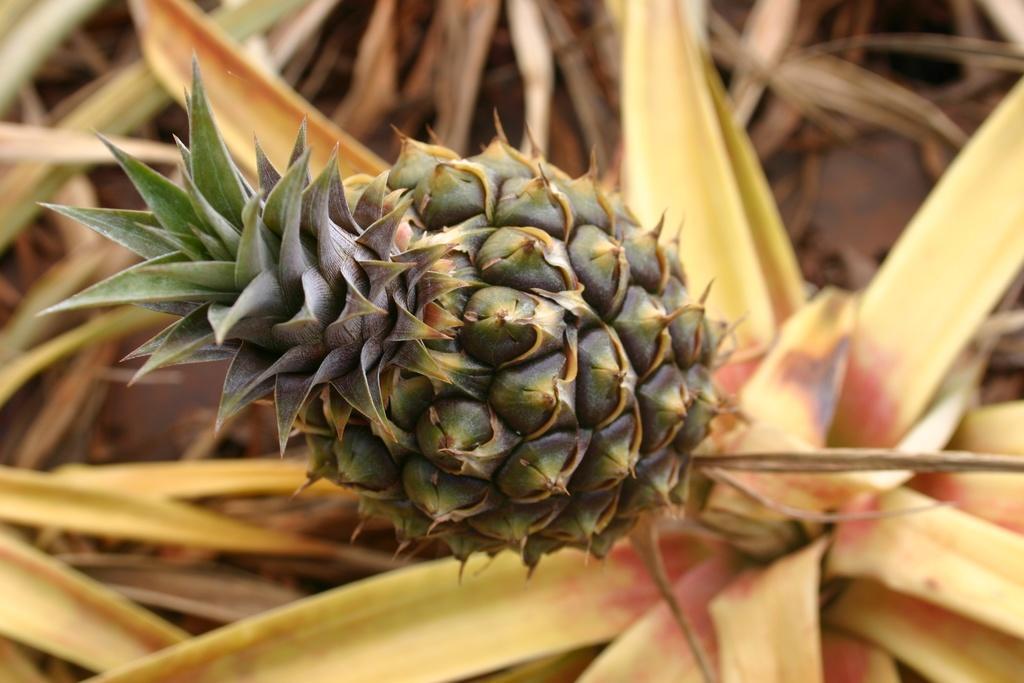How would you summarize this image in a sentence or two? In this image I can see a pineapple. In the background few leaves are visible. 